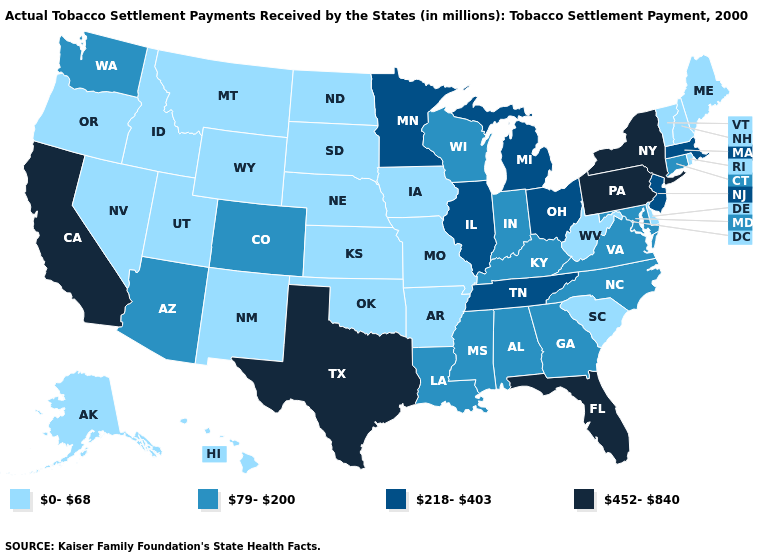Does South Dakota have a lower value than Virginia?
Quick response, please. Yes. Which states have the lowest value in the USA?
Quick response, please. Alaska, Arkansas, Delaware, Hawaii, Idaho, Iowa, Kansas, Maine, Missouri, Montana, Nebraska, Nevada, New Hampshire, New Mexico, North Dakota, Oklahoma, Oregon, Rhode Island, South Carolina, South Dakota, Utah, Vermont, West Virginia, Wyoming. Name the states that have a value in the range 218-403?
Quick response, please. Illinois, Massachusetts, Michigan, Minnesota, New Jersey, Ohio, Tennessee. Is the legend a continuous bar?
Write a very short answer. No. What is the highest value in the USA?
Short answer required. 452-840. Among the states that border Michigan , which have the highest value?
Quick response, please. Ohio. How many symbols are there in the legend?
Keep it brief. 4. Name the states that have a value in the range 0-68?
Keep it brief. Alaska, Arkansas, Delaware, Hawaii, Idaho, Iowa, Kansas, Maine, Missouri, Montana, Nebraska, Nevada, New Hampshire, New Mexico, North Dakota, Oklahoma, Oregon, Rhode Island, South Carolina, South Dakota, Utah, Vermont, West Virginia, Wyoming. How many symbols are there in the legend?
Be succinct. 4. Name the states that have a value in the range 0-68?
Write a very short answer. Alaska, Arkansas, Delaware, Hawaii, Idaho, Iowa, Kansas, Maine, Missouri, Montana, Nebraska, Nevada, New Hampshire, New Mexico, North Dakota, Oklahoma, Oregon, Rhode Island, South Carolina, South Dakota, Utah, Vermont, West Virginia, Wyoming. Does New Jersey have the same value as Illinois?
Quick response, please. Yes. What is the lowest value in the USA?
Give a very brief answer. 0-68. 